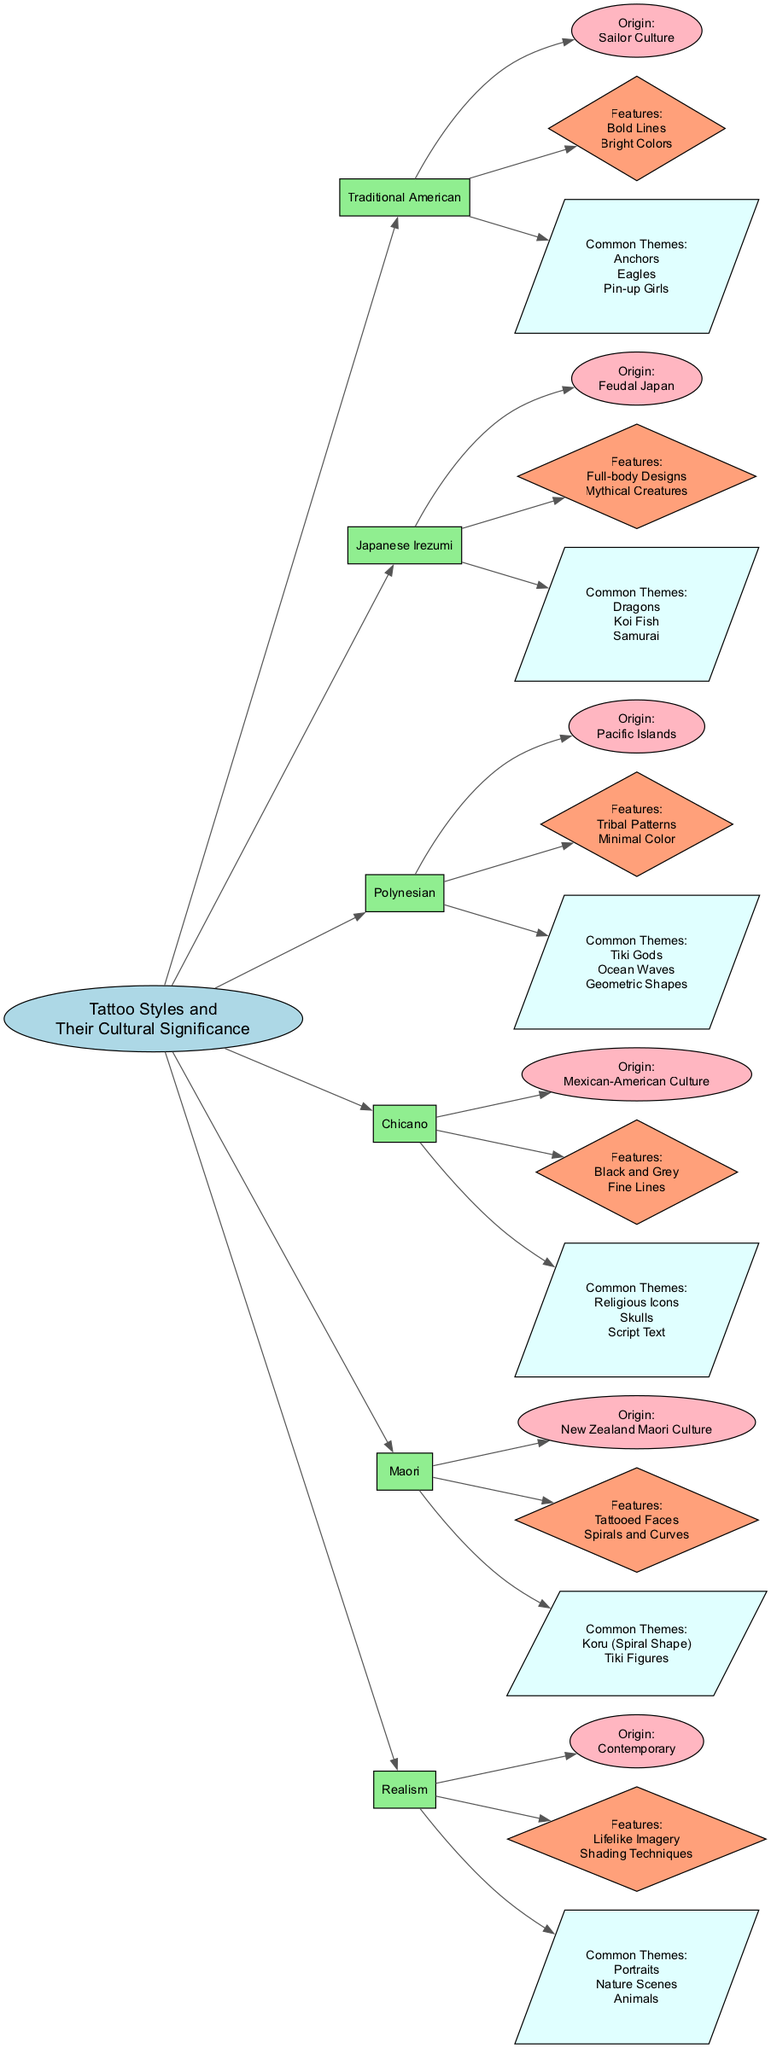What is the origin of Traditional American tattoo style? The diagram clearly states that the origin of the Traditional American tattoo style is "Sailor Culture." This information is located directly connected to the Traditional American node.
Answer: Sailor Culture How many common themes does the Japanese Irezumi tattoo style have? The Japanese Irezumi tattoo style node has three common themes listed: "Dragons," "Koi Fish," and "Samurai." This results in a count of three themes.
Answer: 3 Which tattoo style has "Tribal Patterns" as a feature? According to the diagram, the Polynesian tattoo style lists "Tribal Patterns" among its features. This indicates that the Polynesian style is associated with that particular feature.
Answer: Polynesian What types of designs are included in the features of Realism tattoo style? The features node for Realism lists "Lifelike Imagery" and "Shading Techniques" which indicate the type of detailed designs associated with this style. This shows that Realism focuses on such techniques.
Answer: Lifelike Imagery, Shading Techniques Which common theme is shared between Chicano and Maori tattoo styles? By analyzing the common themes for both the Chicano and Maori tattoo styles, we find that none of the themes overlap, hence indicating that they do not share a common theme based on the diagram.
Answer: None What is a distinguishing feature of the Maori tattoo style? The diagram specifies that one distinguishing feature of the Maori tattoo style is "Tattooed Faces." This phrase is directly connected to the Maori tattoo style node as a characteristic feature.
Answer: Tattooed Faces Count the number of tattoo styles presented in the diagram. By counting the nodes under "Tattoo Styles and Their Cultural Significance," we see there are six different styles listed: Traditional American, Japanese Irezumi, Polynesian, Chicano, Maori, and Realism. This gives us a total of six styles.
Answer: 6 What color is commonly associated with the Chicano tattoo style's features? The Chicano tattoo style features "Black and Grey" as specified in the diagram. This indicates that the colors associated with Chicano tattoos are primarily black and grey.
Answer: Black and Grey List one common theme of the Polynesian tattoo style. The diagram lists several common themes for the Polynesian tattoo style. Choosing any of them, such as "Tiki Gods," fulfills the question as it is directly presented within the relevant section of the diagram.
Answer: Tiki Gods 